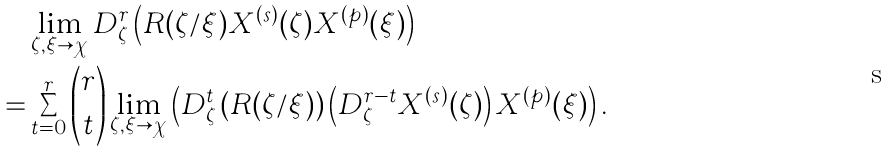<formula> <loc_0><loc_0><loc_500><loc_500>& \lim _ { \zeta , \xi \to \chi } D _ { \zeta } ^ { r } \left ( R ( \zeta / \xi ) X ^ { ( s ) } ( \zeta ) X ^ { ( p ) } ( \xi ) \right ) \\ = & \sum _ { t = 0 } ^ { r } \binom { r } { t } \lim _ { \zeta , \xi \to \chi } \left ( D _ { \zeta } ^ { t } \left ( R ( \zeta / \xi ) \right ) \left ( D _ { \zeta } ^ { r - t } X ^ { ( s ) } ( \zeta ) \right ) X ^ { ( p ) } ( \xi ) \right ) .</formula> 